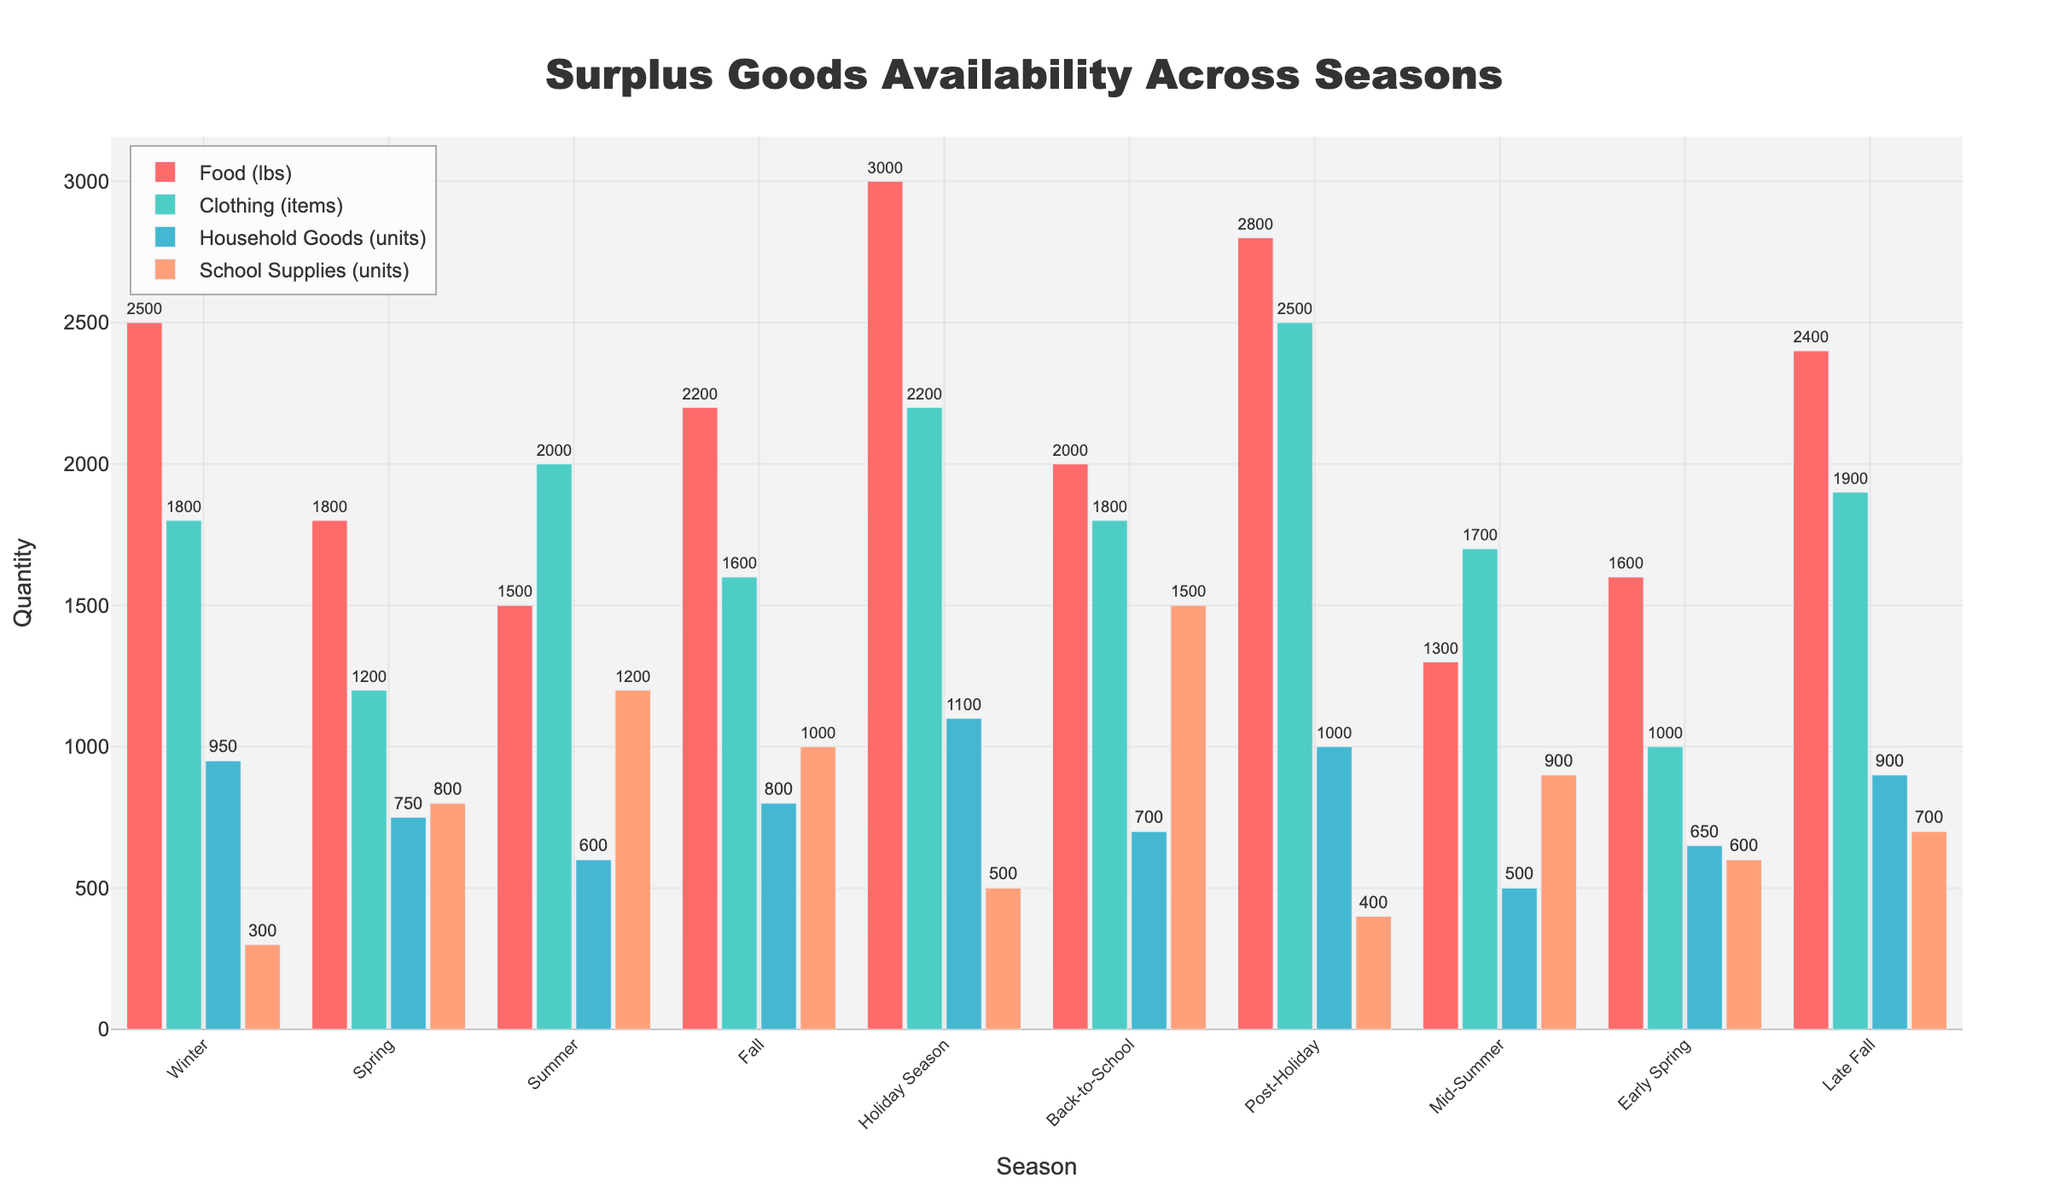Who has the highest availability of school supplies? Look at the school supplies bar for each season and identify the tallest one. The highest bar among school supplies is in the Back-to-School season.
Answer: Back-to-School Comparing winter and spring, which season has more food available? Compare the heights of the food bars for winter and spring. The winter bar is taller than the spring bar.
Answer: Winter What is the total amount of clothing available in the holiday season and post-holiday season combined? Add the values of the clothing items for the holiday season (2200) and post-holiday season (2500). The sum is 2200 + 2500.
Answer: 4700 Which season has the least amount of household goods available? Look across the household goods bars and identify the shortest one. The shortest bar for household goods is in Mid-Summer.
Answer: Mid-Summer How does the availability of food in early spring compare to late fall? Compare the heights of the food bars for early spring (1600) and late fall (2400). The late fall bar is taller.
Answer: Late Fall If you combine the quantities of food and school supplies available in the fall season, what is the total? Sum up the values of food (2200) and school supplies (1000) for the fall season. The total is 2200 + 1000.
Answer: 3200 Is summer offering more or less clothing than winter? Compare the clothing bars for summer (2000) and winter (1800). The summer bar is taller than the winter bar.
Answer: More What is the difference in the availability of household goods between winter and spring? Subtract the value of household goods in spring (750) from that in winter (950). The difference is 950 - 750.
Answer: 200 Which season has the highest combined amount of all surplus goods (food, clothing, household goods, and school supplies)? Sum up the values of all categories for each season and compare the totals. The holiday season has the highest combined total (3000 + 2200 + 1100 + 500 = 6800).
Answer: Holiday Season 